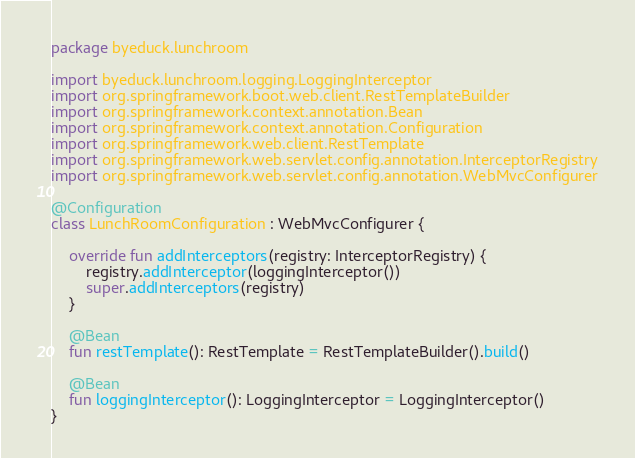Convert code to text. <code><loc_0><loc_0><loc_500><loc_500><_Kotlin_>package byeduck.lunchroom

import byeduck.lunchroom.logging.LoggingInterceptor
import org.springframework.boot.web.client.RestTemplateBuilder
import org.springframework.context.annotation.Bean
import org.springframework.context.annotation.Configuration
import org.springframework.web.client.RestTemplate
import org.springframework.web.servlet.config.annotation.InterceptorRegistry
import org.springframework.web.servlet.config.annotation.WebMvcConfigurer

@Configuration
class LunchRoomConfiguration : WebMvcConfigurer {

    override fun addInterceptors(registry: InterceptorRegistry) {
        registry.addInterceptor(loggingInterceptor())
        super.addInterceptors(registry)
    }

    @Bean
    fun restTemplate(): RestTemplate = RestTemplateBuilder().build()

    @Bean
    fun loggingInterceptor(): LoggingInterceptor = LoggingInterceptor()
}</code> 